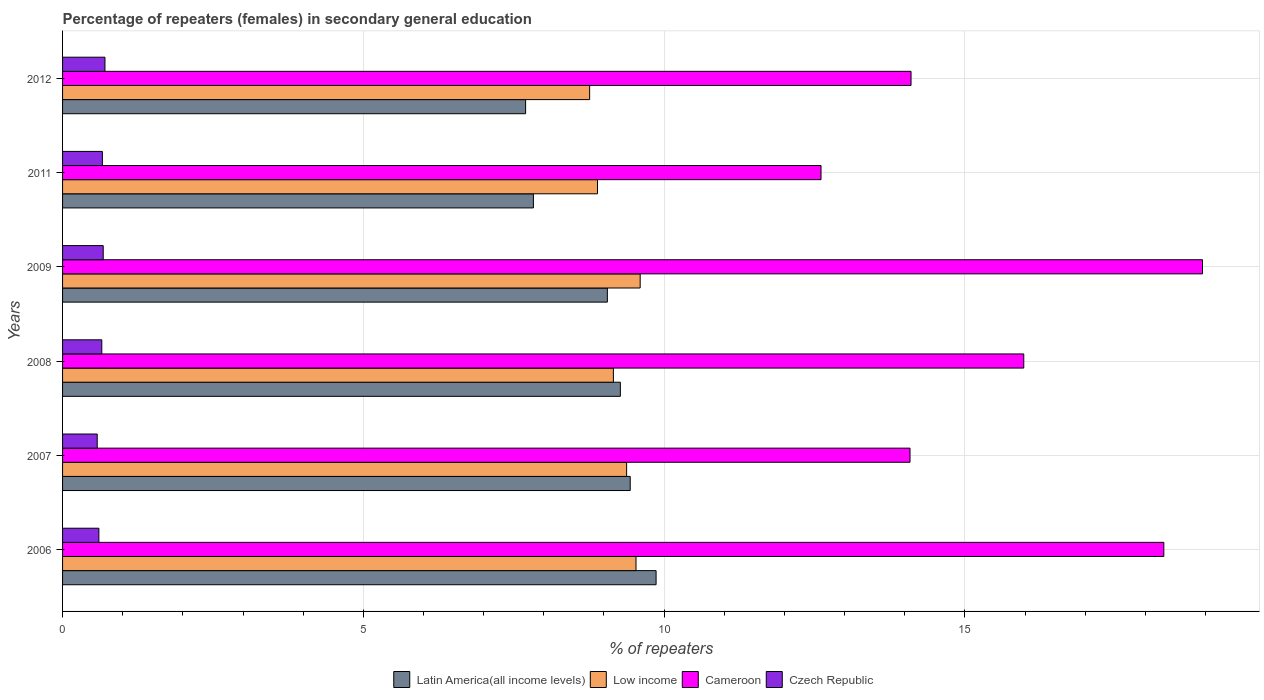Are the number of bars per tick equal to the number of legend labels?
Provide a succinct answer. Yes. How many bars are there on the 5th tick from the top?
Give a very brief answer. 4. How many bars are there on the 1st tick from the bottom?
Give a very brief answer. 4. What is the label of the 1st group of bars from the top?
Give a very brief answer. 2012. In how many cases, is the number of bars for a given year not equal to the number of legend labels?
Make the answer very short. 0. What is the percentage of female repeaters in Latin America(all income levels) in 2008?
Ensure brevity in your answer.  9.27. Across all years, what is the maximum percentage of female repeaters in Cameroon?
Your answer should be compact. 18.95. Across all years, what is the minimum percentage of female repeaters in Czech Republic?
Keep it short and to the point. 0.58. What is the total percentage of female repeaters in Czech Republic in the graph?
Your answer should be very brief. 3.87. What is the difference between the percentage of female repeaters in Low income in 2011 and that in 2012?
Provide a succinct answer. 0.13. What is the difference between the percentage of female repeaters in Low income in 2011 and the percentage of female repeaters in Czech Republic in 2008?
Give a very brief answer. 8.24. What is the average percentage of female repeaters in Czech Republic per year?
Keep it short and to the point. 0.65. In the year 2006, what is the difference between the percentage of female repeaters in Cameroon and percentage of female repeaters in Low income?
Your response must be concise. 8.77. In how many years, is the percentage of female repeaters in Latin America(all income levels) greater than 4 %?
Your answer should be compact. 6. What is the ratio of the percentage of female repeaters in Low income in 2011 to that in 2012?
Your answer should be compact. 1.01. Is the difference between the percentage of female repeaters in Cameroon in 2008 and 2009 greater than the difference between the percentage of female repeaters in Low income in 2008 and 2009?
Provide a succinct answer. No. What is the difference between the highest and the second highest percentage of female repeaters in Czech Republic?
Provide a short and direct response. 0.03. What is the difference between the highest and the lowest percentage of female repeaters in Latin America(all income levels)?
Your answer should be very brief. 2.17. What does the 3rd bar from the top in 2009 represents?
Give a very brief answer. Low income. What does the 3rd bar from the bottom in 2007 represents?
Make the answer very short. Cameroon. How many bars are there?
Provide a short and direct response. 24. How many years are there in the graph?
Your answer should be compact. 6. Are the values on the major ticks of X-axis written in scientific E-notation?
Give a very brief answer. No. Does the graph contain grids?
Ensure brevity in your answer.  Yes. Where does the legend appear in the graph?
Your response must be concise. Bottom center. What is the title of the graph?
Your response must be concise. Percentage of repeaters (females) in secondary general education. What is the label or title of the X-axis?
Provide a succinct answer. % of repeaters. What is the % of repeaters of Latin America(all income levels) in 2006?
Your answer should be compact. 9.87. What is the % of repeaters of Low income in 2006?
Keep it short and to the point. 9.53. What is the % of repeaters of Cameroon in 2006?
Give a very brief answer. 18.31. What is the % of repeaters in Czech Republic in 2006?
Provide a succinct answer. 0.6. What is the % of repeaters in Latin America(all income levels) in 2007?
Provide a short and direct response. 9.44. What is the % of repeaters of Low income in 2007?
Offer a very short reply. 9.38. What is the % of repeaters of Cameroon in 2007?
Provide a succinct answer. 14.09. What is the % of repeaters of Czech Republic in 2007?
Make the answer very short. 0.58. What is the % of repeaters of Latin America(all income levels) in 2008?
Provide a short and direct response. 9.27. What is the % of repeaters of Low income in 2008?
Your answer should be very brief. 9.16. What is the % of repeaters of Cameroon in 2008?
Offer a terse response. 15.98. What is the % of repeaters of Czech Republic in 2008?
Offer a very short reply. 0.65. What is the % of repeaters of Latin America(all income levels) in 2009?
Offer a very short reply. 9.06. What is the % of repeaters in Low income in 2009?
Keep it short and to the point. 9.6. What is the % of repeaters in Cameroon in 2009?
Keep it short and to the point. 18.95. What is the % of repeaters in Czech Republic in 2009?
Keep it short and to the point. 0.68. What is the % of repeaters in Latin America(all income levels) in 2011?
Your answer should be very brief. 7.83. What is the % of repeaters of Low income in 2011?
Make the answer very short. 8.89. What is the % of repeaters of Cameroon in 2011?
Keep it short and to the point. 12.61. What is the % of repeaters in Czech Republic in 2011?
Provide a succinct answer. 0.66. What is the % of repeaters in Latin America(all income levels) in 2012?
Keep it short and to the point. 7.7. What is the % of repeaters of Low income in 2012?
Make the answer very short. 8.76. What is the % of repeaters of Cameroon in 2012?
Ensure brevity in your answer.  14.1. What is the % of repeaters of Czech Republic in 2012?
Ensure brevity in your answer.  0.7. Across all years, what is the maximum % of repeaters of Latin America(all income levels)?
Ensure brevity in your answer.  9.87. Across all years, what is the maximum % of repeaters of Low income?
Give a very brief answer. 9.6. Across all years, what is the maximum % of repeaters of Cameroon?
Offer a terse response. 18.95. Across all years, what is the maximum % of repeaters in Czech Republic?
Ensure brevity in your answer.  0.7. Across all years, what is the minimum % of repeaters in Latin America(all income levels)?
Your answer should be very brief. 7.7. Across all years, what is the minimum % of repeaters in Low income?
Give a very brief answer. 8.76. Across all years, what is the minimum % of repeaters of Cameroon?
Your response must be concise. 12.61. Across all years, what is the minimum % of repeaters in Czech Republic?
Your response must be concise. 0.58. What is the total % of repeaters in Latin America(all income levels) in the graph?
Offer a very short reply. 53.16. What is the total % of repeaters of Low income in the graph?
Your answer should be compact. 55.32. What is the total % of repeaters of Cameroon in the graph?
Make the answer very short. 94.03. What is the total % of repeaters in Czech Republic in the graph?
Make the answer very short. 3.87. What is the difference between the % of repeaters in Latin America(all income levels) in 2006 and that in 2007?
Offer a terse response. 0.43. What is the difference between the % of repeaters of Low income in 2006 and that in 2007?
Offer a terse response. 0.16. What is the difference between the % of repeaters in Cameroon in 2006 and that in 2007?
Your response must be concise. 4.22. What is the difference between the % of repeaters of Czech Republic in 2006 and that in 2007?
Keep it short and to the point. 0.03. What is the difference between the % of repeaters in Latin America(all income levels) in 2006 and that in 2008?
Ensure brevity in your answer.  0.59. What is the difference between the % of repeaters of Low income in 2006 and that in 2008?
Give a very brief answer. 0.38. What is the difference between the % of repeaters of Cameroon in 2006 and that in 2008?
Your answer should be very brief. 2.33. What is the difference between the % of repeaters in Czech Republic in 2006 and that in 2008?
Offer a terse response. -0.05. What is the difference between the % of repeaters of Latin America(all income levels) in 2006 and that in 2009?
Your response must be concise. 0.81. What is the difference between the % of repeaters in Low income in 2006 and that in 2009?
Offer a very short reply. -0.07. What is the difference between the % of repeaters in Cameroon in 2006 and that in 2009?
Your answer should be very brief. -0.64. What is the difference between the % of repeaters in Czech Republic in 2006 and that in 2009?
Your answer should be compact. -0.07. What is the difference between the % of repeaters in Latin America(all income levels) in 2006 and that in 2011?
Provide a succinct answer. 2.04. What is the difference between the % of repeaters of Low income in 2006 and that in 2011?
Provide a succinct answer. 0.64. What is the difference between the % of repeaters of Cameroon in 2006 and that in 2011?
Offer a terse response. 5.7. What is the difference between the % of repeaters of Czech Republic in 2006 and that in 2011?
Your response must be concise. -0.06. What is the difference between the % of repeaters in Latin America(all income levels) in 2006 and that in 2012?
Your answer should be compact. 2.17. What is the difference between the % of repeaters in Low income in 2006 and that in 2012?
Your response must be concise. 0.77. What is the difference between the % of repeaters of Cameroon in 2006 and that in 2012?
Offer a terse response. 4.2. What is the difference between the % of repeaters in Czech Republic in 2006 and that in 2012?
Offer a terse response. -0.1. What is the difference between the % of repeaters in Latin America(all income levels) in 2007 and that in 2008?
Provide a succinct answer. 0.16. What is the difference between the % of repeaters of Low income in 2007 and that in 2008?
Offer a terse response. 0.22. What is the difference between the % of repeaters of Cameroon in 2007 and that in 2008?
Provide a succinct answer. -1.89. What is the difference between the % of repeaters in Czech Republic in 2007 and that in 2008?
Provide a succinct answer. -0.08. What is the difference between the % of repeaters in Latin America(all income levels) in 2007 and that in 2009?
Offer a very short reply. 0.38. What is the difference between the % of repeaters of Low income in 2007 and that in 2009?
Provide a succinct answer. -0.23. What is the difference between the % of repeaters in Cameroon in 2007 and that in 2009?
Your response must be concise. -4.86. What is the difference between the % of repeaters in Czech Republic in 2007 and that in 2009?
Provide a short and direct response. -0.1. What is the difference between the % of repeaters in Latin America(all income levels) in 2007 and that in 2011?
Provide a succinct answer. 1.61. What is the difference between the % of repeaters in Low income in 2007 and that in 2011?
Your answer should be very brief. 0.48. What is the difference between the % of repeaters of Cameroon in 2007 and that in 2011?
Provide a succinct answer. 1.48. What is the difference between the % of repeaters in Czech Republic in 2007 and that in 2011?
Keep it short and to the point. -0.09. What is the difference between the % of repeaters of Latin America(all income levels) in 2007 and that in 2012?
Offer a very short reply. 1.74. What is the difference between the % of repeaters in Low income in 2007 and that in 2012?
Keep it short and to the point. 0.61. What is the difference between the % of repeaters of Cameroon in 2007 and that in 2012?
Offer a terse response. -0.02. What is the difference between the % of repeaters of Czech Republic in 2007 and that in 2012?
Keep it short and to the point. -0.13. What is the difference between the % of repeaters of Latin America(all income levels) in 2008 and that in 2009?
Your answer should be very brief. 0.22. What is the difference between the % of repeaters in Low income in 2008 and that in 2009?
Give a very brief answer. -0.45. What is the difference between the % of repeaters in Cameroon in 2008 and that in 2009?
Offer a very short reply. -2.97. What is the difference between the % of repeaters in Czech Republic in 2008 and that in 2009?
Your answer should be very brief. -0.02. What is the difference between the % of repeaters in Latin America(all income levels) in 2008 and that in 2011?
Provide a succinct answer. 1.45. What is the difference between the % of repeaters in Low income in 2008 and that in 2011?
Provide a succinct answer. 0.26. What is the difference between the % of repeaters in Cameroon in 2008 and that in 2011?
Ensure brevity in your answer.  3.37. What is the difference between the % of repeaters of Czech Republic in 2008 and that in 2011?
Provide a succinct answer. -0.01. What is the difference between the % of repeaters of Latin America(all income levels) in 2008 and that in 2012?
Offer a terse response. 1.57. What is the difference between the % of repeaters of Low income in 2008 and that in 2012?
Provide a short and direct response. 0.39. What is the difference between the % of repeaters of Cameroon in 2008 and that in 2012?
Your answer should be very brief. 1.87. What is the difference between the % of repeaters of Czech Republic in 2008 and that in 2012?
Provide a short and direct response. -0.05. What is the difference between the % of repeaters in Latin America(all income levels) in 2009 and that in 2011?
Provide a short and direct response. 1.23. What is the difference between the % of repeaters in Low income in 2009 and that in 2011?
Make the answer very short. 0.71. What is the difference between the % of repeaters of Cameroon in 2009 and that in 2011?
Make the answer very short. 6.34. What is the difference between the % of repeaters in Czech Republic in 2009 and that in 2011?
Provide a short and direct response. 0.01. What is the difference between the % of repeaters of Latin America(all income levels) in 2009 and that in 2012?
Your answer should be very brief. 1.36. What is the difference between the % of repeaters in Low income in 2009 and that in 2012?
Offer a very short reply. 0.84. What is the difference between the % of repeaters of Cameroon in 2009 and that in 2012?
Keep it short and to the point. 4.85. What is the difference between the % of repeaters in Czech Republic in 2009 and that in 2012?
Give a very brief answer. -0.03. What is the difference between the % of repeaters of Latin America(all income levels) in 2011 and that in 2012?
Your answer should be very brief. 0.13. What is the difference between the % of repeaters in Low income in 2011 and that in 2012?
Give a very brief answer. 0.13. What is the difference between the % of repeaters of Cameroon in 2011 and that in 2012?
Make the answer very short. -1.5. What is the difference between the % of repeaters in Czech Republic in 2011 and that in 2012?
Make the answer very short. -0.04. What is the difference between the % of repeaters in Latin America(all income levels) in 2006 and the % of repeaters in Low income in 2007?
Offer a very short reply. 0.49. What is the difference between the % of repeaters of Latin America(all income levels) in 2006 and the % of repeaters of Cameroon in 2007?
Offer a very short reply. -4.22. What is the difference between the % of repeaters of Latin America(all income levels) in 2006 and the % of repeaters of Czech Republic in 2007?
Your answer should be compact. 9.29. What is the difference between the % of repeaters of Low income in 2006 and the % of repeaters of Cameroon in 2007?
Give a very brief answer. -4.55. What is the difference between the % of repeaters of Low income in 2006 and the % of repeaters of Czech Republic in 2007?
Your response must be concise. 8.96. What is the difference between the % of repeaters of Cameroon in 2006 and the % of repeaters of Czech Republic in 2007?
Your answer should be compact. 17.73. What is the difference between the % of repeaters in Latin America(all income levels) in 2006 and the % of repeaters in Low income in 2008?
Give a very brief answer. 0.71. What is the difference between the % of repeaters in Latin America(all income levels) in 2006 and the % of repeaters in Cameroon in 2008?
Your response must be concise. -6.11. What is the difference between the % of repeaters in Latin America(all income levels) in 2006 and the % of repeaters in Czech Republic in 2008?
Your answer should be very brief. 9.21. What is the difference between the % of repeaters of Low income in 2006 and the % of repeaters of Cameroon in 2008?
Give a very brief answer. -6.45. What is the difference between the % of repeaters of Low income in 2006 and the % of repeaters of Czech Republic in 2008?
Keep it short and to the point. 8.88. What is the difference between the % of repeaters of Cameroon in 2006 and the % of repeaters of Czech Republic in 2008?
Provide a succinct answer. 17.65. What is the difference between the % of repeaters of Latin America(all income levels) in 2006 and the % of repeaters of Low income in 2009?
Your response must be concise. 0.26. What is the difference between the % of repeaters in Latin America(all income levels) in 2006 and the % of repeaters in Cameroon in 2009?
Provide a succinct answer. -9.08. What is the difference between the % of repeaters in Latin America(all income levels) in 2006 and the % of repeaters in Czech Republic in 2009?
Make the answer very short. 9.19. What is the difference between the % of repeaters of Low income in 2006 and the % of repeaters of Cameroon in 2009?
Your response must be concise. -9.42. What is the difference between the % of repeaters of Low income in 2006 and the % of repeaters of Czech Republic in 2009?
Keep it short and to the point. 8.86. What is the difference between the % of repeaters in Cameroon in 2006 and the % of repeaters in Czech Republic in 2009?
Ensure brevity in your answer.  17.63. What is the difference between the % of repeaters of Latin America(all income levels) in 2006 and the % of repeaters of Low income in 2011?
Make the answer very short. 0.97. What is the difference between the % of repeaters of Latin America(all income levels) in 2006 and the % of repeaters of Cameroon in 2011?
Your answer should be very brief. -2.74. What is the difference between the % of repeaters of Latin America(all income levels) in 2006 and the % of repeaters of Czech Republic in 2011?
Your answer should be very brief. 9.2. What is the difference between the % of repeaters of Low income in 2006 and the % of repeaters of Cameroon in 2011?
Your answer should be very brief. -3.08. What is the difference between the % of repeaters in Low income in 2006 and the % of repeaters in Czech Republic in 2011?
Ensure brevity in your answer.  8.87. What is the difference between the % of repeaters of Cameroon in 2006 and the % of repeaters of Czech Republic in 2011?
Keep it short and to the point. 17.64. What is the difference between the % of repeaters of Latin America(all income levels) in 2006 and the % of repeaters of Low income in 2012?
Your answer should be compact. 1.1. What is the difference between the % of repeaters in Latin America(all income levels) in 2006 and the % of repeaters in Cameroon in 2012?
Your response must be concise. -4.24. What is the difference between the % of repeaters of Latin America(all income levels) in 2006 and the % of repeaters of Czech Republic in 2012?
Your response must be concise. 9.16. What is the difference between the % of repeaters of Low income in 2006 and the % of repeaters of Cameroon in 2012?
Ensure brevity in your answer.  -4.57. What is the difference between the % of repeaters of Low income in 2006 and the % of repeaters of Czech Republic in 2012?
Provide a short and direct response. 8.83. What is the difference between the % of repeaters in Cameroon in 2006 and the % of repeaters in Czech Republic in 2012?
Your answer should be compact. 17.6. What is the difference between the % of repeaters in Latin America(all income levels) in 2007 and the % of repeaters in Low income in 2008?
Give a very brief answer. 0.28. What is the difference between the % of repeaters in Latin America(all income levels) in 2007 and the % of repeaters in Cameroon in 2008?
Provide a succinct answer. -6.54. What is the difference between the % of repeaters of Latin America(all income levels) in 2007 and the % of repeaters of Czech Republic in 2008?
Provide a short and direct response. 8.78. What is the difference between the % of repeaters of Low income in 2007 and the % of repeaters of Cameroon in 2008?
Your answer should be compact. -6.6. What is the difference between the % of repeaters in Low income in 2007 and the % of repeaters in Czech Republic in 2008?
Offer a very short reply. 8.72. What is the difference between the % of repeaters of Cameroon in 2007 and the % of repeaters of Czech Republic in 2008?
Offer a terse response. 13.44. What is the difference between the % of repeaters of Latin America(all income levels) in 2007 and the % of repeaters of Low income in 2009?
Give a very brief answer. -0.17. What is the difference between the % of repeaters of Latin America(all income levels) in 2007 and the % of repeaters of Cameroon in 2009?
Make the answer very short. -9.51. What is the difference between the % of repeaters in Latin America(all income levels) in 2007 and the % of repeaters in Czech Republic in 2009?
Your answer should be very brief. 8.76. What is the difference between the % of repeaters in Low income in 2007 and the % of repeaters in Cameroon in 2009?
Offer a terse response. -9.57. What is the difference between the % of repeaters in Low income in 2007 and the % of repeaters in Czech Republic in 2009?
Ensure brevity in your answer.  8.7. What is the difference between the % of repeaters in Cameroon in 2007 and the % of repeaters in Czech Republic in 2009?
Your answer should be compact. 13.41. What is the difference between the % of repeaters in Latin America(all income levels) in 2007 and the % of repeaters in Low income in 2011?
Your answer should be compact. 0.54. What is the difference between the % of repeaters of Latin America(all income levels) in 2007 and the % of repeaters of Cameroon in 2011?
Give a very brief answer. -3.17. What is the difference between the % of repeaters of Latin America(all income levels) in 2007 and the % of repeaters of Czech Republic in 2011?
Offer a terse response. 8.77. What is the difference between the % of repeaters of Low income in 2007 and the % of repeaters of Cameroon in 2011?
Provide a succinct answer. -3.23. What is the difference between the % of repeaters of Low income in 2007 and the % of repeaters of Czech Republic in 2011?
Your answer should be very brief. 8.71. What is the difference between the % of repeaters in Cameroon in 2007 and the % of repeaters in Czech Republic in 2011?
Give a very brief answer. 13.43. What is the difference between the % of repeaters in Latin America(all income levels) in 2007 and the % of repeaters in Low income in 2012?
Offer a very short reply. 0.67. What is the difference between the % of repeaters of Latin America(all income levels) in 2007 and the % of repeaters of Cameroon in 2012?
Ensure brevity in your answer.  -4.67. What is the difference between the % of repeaters of Latin America(all income levels) in 2007 and the % of repeaters of Czech Republic in 2012?
Provide a succinct answer. 8.73. What is the difference between the % of repeaters in Low income in 2007 and the % of repeaters in Cameroon in 2012?
Provide a succinct answer. -4.73. What is the difference between the % of repeaters in Low income in 2007 and the % of repeaters in Czech Republic in 2012?
Offer a terse response. 8.67. What is the difference between the % of repeaters of Cameroon in 2007 and the % of repeaters of Czech Republic in 2012?
Offer a terse response. 13.38. What is the difference between the % of repeaters in Latin America(all income levels) in 2008 and the % of repeaters in Low income in 2009?
Offer a very short reply. -0.33. What is the difference between the % of repeaters in Latin America(all income levels) in 2008 and the % of repeaters in Cameroon in 2009?
Provide a succinct answer. -9.68. What is the difference between the % of repeaters of Latin America(all income levels) in 2008 and the % of repeaters of Czech Republic in 2009?
Your answer should be very brief. 8.6. What is the difference between the % of repeaters in Low income in 2008 and the % of repeaters in Cameroon in 2009?
Your answer should be compact. -9.79. What is the difference between the % of repeaters in Low income in 2008 and the % of repeaters in Czech Republic in 2009?
Your answer should be very brief. 8.48. What is the difference between the % of repeaters in Cameroon in 2008 and the % of repeaters in Czech Republic in 2009?
Ensure brevity in your answer.  15.3. What is the difference between the % of repeaters of Latin America(all income levels) in 2008 and the % of repeaters of Low income in 2011?
Make the answer very short. 0.38. What is the difference between the % of repeaters of Latin America(all income levels) in 2008 and the % of repeaters of Cameroon in 2011?
Make the answer very short. -3.34. What is the difference between the % of repeaters in Latin America(all income levels) in 2008 and the % of repeaters in Czech Republic in 2011?
Give a very brief answer. 8.61. What is the difference between the % of repeaters of Low income in 2008 and the % of repeaters of Cameroon in 2011?
Keep it short and to the point. -3.45. What is the difference between the % of repeaters in Low income in 2008 and the % of repeaters in Czech Republic in 2011?
Offer a very short reply. 8.49. What is the difference between the % of repeaters in Cameroon in 2008 and the % of repeaters in Czech Republic in 2011?
Provide a succinct answer. 15.32. What is the difference between the % of repeaters of Latin America(all income levels) in 2008 and the % of repeaters of Low income in 2012?
Give a very brief answer. 0.51. What is the difference between the % of repeaters in Latin America(all income levels) in 2008 and the % of repeaters in Cameroon in 2012?
Ensure brevity in your answer.  -4.83. What is the difference between the % of repeaters in Latin America(all income levels) in 2008 and the % of repeaters in Czech Republic in 2012?
Ensure brevity in your answer.  8.57. What is the difference between the % of repeaters of Low income in 2008 and the % of repeaters of Cameroon in 2012?
Make the answer very short. -4.95. What is the difference between the % of repeaters in Low income in 2008 and the % of repeaters in Czech Republic in 2012?
Offer a very short reply. 8.45. What is the difference between the % of repeaters in Cameroon in 2008 and the % of repeaters in Czech Republic in 2012?
Give a very brief answer. 15.27. What is the difference between the % of repeaters in Latin America(all income levels) in 2009 and the % of repeaters in Low income in 2011?
Provide a succinct answer. 0.16. What is the difference between the % of repeaters in Latin America(all income levels) in 2009 and the % of repeaters in Cameroon in 2011?
Offer a terse response. -3.55. What is the difference between the % of repeaters of Latin America(all income levels) in 2009 and the % of repeaters of Czech Republic in 2011?
Ensure brevity in your answer.  8.39. What is the difference between the % of repeaters in Low income in 2009 and the % of repeaters in Cameroon in 2011?
Keep it short and to the point. -3.01. What is the difference between the % of repeaters of Low income in 2009 and the % of repeaters of Czech Republic in 2011?
Provide a short and direct response. 8.94. What is the difference between the % of repeaters in Cameroon in 2009 and the % of repeaters in Czech Republic in 2011?
Provide a succinct answer. 18.29. What is the difference between the % of repeaters of Latin America(all income levels) in 2009 and the % of repeaters of Low income in 2012?
Provide a short and direct response. 0.29. What is the difference between the % of repeaters of Latin America(all income levels) in 2009 and the % of repeaters of Cameroon in 2012?
Provide a succinct answer. -5.05. What is the difference between the % of repeaters in Latin America(all income levels) in 2009 and the % of repeaters in Czech Republic in 2012?
Give a very brief answer. 8.35. What is the difference between the % of repeaters in Low income in 2009 and the % of repeaters in Cameroon in 2012?
Provide a short and direct response. -4.5. What is the difference between the % of repeaters in Low income in 2009 and the % of repeaters in Czech Republic in 2012?
Provide a succinct answer. 8.9. What is the difference between the % of repeaters in Cameroon in 2009 and the % of repeaters in Czech Republic in 2012?
Offer a terse response. 18.24. What is the difference between the % of repeaters in Latin America(all income levels) in 2011 and the % of repeaters in Low income in 2012?
Give a very brief answer. -0.93. What is the difference between the % of repeaters in Latin America(all income levels) in 2011 and the % of repeaters in Cameroon in 2012?
Offer a very short reply. -6.28. What is the difference between the % of repeaters in Latin America(all income levels) in 2011 and the % of repeaters in Czech Republic in 2012?
Your answer should be very brief. 7.12. What is the difference between the % of repeaters of Low income in 2011 and the % of repeaters of Cameroon in 2012?
Make the answer very short. -5.21. What is the difference between the % of repeaters in Low income in 2011 and the % of repeaters in Czech Republic in 2012?
Provide a succinct answer. 8.19. What is the difference between the % of repeaters in Cameroon in 2011 and the % of repeaters in Czech Republic in 2012?
Offer a very short reply. 11.9. What is the average % of repeaters of Latin America(all income levels) per year?
Your answer should be very brief. 8.86. What is the average % of repeaters of Low income per year?
Offer a very short reply. 9.22. What is the average % of repeaters of Cameroon per year?
Offer a terse response. 15.67. What is the average % of repeaters of Czech Republic per year?
Your answer should be compact. 0.65. In the year 2006, what is the difference between the % of repeaters in Latin America(all income levels) and % of repeaters in Low income?
Keep it short and to the point. 0.33. In the year 2006, what is the difference between the % of repeaters of Latin America(all income levels) and % of repeaters of Cameroon?
Make the answer very short. -8.44. In the year 2006, what is the difference between the % of repeaters of Latin America(all income levels) and % of repeaters of Czech Republic?
Offer a terse response. 9.26. In the year 2006, what is the difference between the % of repeaters of Low income and % of repeaters of Cameroon?
Give a very brief answer. -8.77. In the year 2006, what is the difference between the % of repeaters of Low income and % of repeaters of Czech Republic?
Ensure brevity in your answer.  8.93. In the year 2006, what is the difference between the % of repeaters of Cameroon and % of repeaters of Czech Republic?
Give a very brief answer. 17.7. In the year 2007, what is the difference between the % of repeaters of Latin America(all income levels) and % of repeaters of Low income?
Provide a succinct answer. 0.06. In the year 2007, what is the difference between the % of repeaters of Latin America(all income levels) and % of repeaters of Cameroon?
Provide a succinct answer. -4.65. In the year 2007, what is the difference between the % of repeaters in Latin America(all income levels) and % of repeaters in Czech Republic?
Your response must be concise. 8.86. In the year 2007, what is the difference between the % of repeaters of Low income and % of repeaters of Cameroon?
Give a very brief answer. -4.71. In the year 2007, what is the difference between the % of repeaters of Low income and % of repeaters of Czech Republic?
Keep it short and to the point. 8.8. In the year 2007, what is the difference between the % of repeaters in Cameroon and % of repeaters in Czech Republic?
Make the answer very short. 13.51. In the year 2008, what is the difference between the % of repeaters of Latin America(all income levels) and % of repeaters of Low income?
Your answer should be compact. 0.12. In the year 2008, what is the difference between the % of repeaters of Latin America(all income levels) and % of repeaters of Cameroon?
Give a very brief answer. -6.71. In the year 2008, what is the difference between the % of repeaters of Latin America(all income levels) and % of repeaters of Czech Republic?
Offer a very short reply. 8.62. In the year 2008, what is the difference between the % of repeaters in Low income and % of repeaters in Cameroon?
Offer a terse response. -6.82. In the year 2008, what is the difference between the % of repeaters in Low income and % of repeaters in Czech Republic?
Keep it short and to the point. 8.5. In the year 2008, what is the difference between the % of repeaters of Cameroon and % of repeaters of Czech Republic?
Your answer should be compact. 15.33. In the year 2009, what is the difference between the % of repeaters in Latin America(all income levels) and % of repeaters in Low income?
Your response must be concise. -0.55. In the year 2009, what is the difference between the % of repeaters in Latin America(all income levels) and % of repeaters in Cameroon?
Provide a short and direct response. -9.89. In the year 2009, what is the difference between the % of repeaters of Latin America(all income levels) and % of repeaters of Czech Republic?
Ensure brevity in your answer.  8.38. In the year 2009, what is the difference between the % of repeaters of Low income and % of repeaters of Cameroon?
Provide a short and direct response. -9.35. In the year 2009, what is the difference between the % of repeaters in Low income and % of repeaters in Czech Republic?
Provide a succinct answer. 8.93. In the year 2009, what is the difference between the % of repeaters of Cameroon and % of repeaters of Czech Republic?
Offer a very short reply. 18.27. In the year 2011, what is the difference between the % of repeaters of Latin America(all income levels) and % of repeaters of Low income?
Offer a terse response. -1.07. In the year 2011, what is the difference between the % of repeaters in Latin America(all income levels) and % of repeaters in Cameroon?
Provide a short and direct response. -4.78. In the year 2011, what is the difference between the % of repeaters of Latin America(all income levels) and % of repeaters of Czech Republic?
Ensure brevity in your answer.  7.17. In the year 2011, what is the difference between the % of repeaters of Low income and % of repeaters of Cameroon?
Provide a short and direct response. -3.72. In the year 2011, what is the difference between the % of repeaters in Low income and % of repeaters in Czech Republic?
Give a very brief answer. 8.23. In the year 2011, what is the difference between the % of repeaters in Cameroon and % of repeaters in Czech Republic?
Offer a terse response. 11.95. In the year 2012, what is the difference between the % of repeaters of Latin America(all income levels) and % of repeaters of Low income?
Offer a very short reply. -1.06. In the year 2012, what is the difference between the % of repeaters of Latin America(all income levels) and % of repeaters of Cameroon?
Offer a very short reply. -6.41. In the year 2012, what is the difference between the % of repeaters in Latin America(all income levels) and % of repeaters in Czech Republic?
Provide a succinct answer. 6.99. In the year 2012, what is the difference between the % of repeaters of Low income and % of repeaters of Cameroon?
Provide a short and direct response. -5.34. In the year 2012, what is the difference between the % of repeaters in Low income and % of repeaters in Czech Republic?
Give a very brief answer. 8.06. In the year 2012, what is the difference between the % of repeaters in Cameroon and % of repeaters in Czech Republic?
Your answer should be very brief. 13.4. What is the ratio of the % of repeaters in Latin America(all income levels) in 2006 to that in 2007?
Give a very brief answer. 1.05. What is the ratio of the % of repeaters of Low income in 2006 to that in 2007?
Keep it short and to the point. 1.02. What is the ratio of the % of repeaters of Cameroon in 2006 to that in 2007?
Your response must be concise. 1.3. What is the ratio of the % of repeaters in Czech Republic in 2006 to that in 2007?
Give a very brief answer. 1.05. What is the ratio of the % of repeaters of Latin America(all income levels) in 2006 to that in 2008?
Keep it short and to the point. 1.06. What is the ratio of the % of repeaters of Low income in 2006 to that in 2008?
Your answer should be very brief. 1.04. What is the ratio of the % of repeaters of Cameroon in 2006 to that in 2008?
Your answer should be very brief. 1.15. What is the ratio of the % of repeaters of Czech Republic in 2006 to that in 2008?
Give a very brief answer. 0.93. What is the ratio of the % of repeaters in Latin America(all income levels) in 2006 to that in 2009?
Offer a terse response. 1.09. What is the ratio of the % of repeaters of Low income in 2006 to that in 2009?
Your answer should be compact. 0.99. What is the ratio of the % of repeaters in Cameroon in 2006 to that in 2009?
Make the answer very short. 0.97. What is the ratio of the % of repeaters of Czech Republic in 2006 to that in 2009?
Give a very brief answer. 0.89. What is the ratio of the % of repeaters of Latin America(all income levels) in 2006 to that in 2011?
Give a very brief answer. 1.26. What is the ratio of the % of repeaters in Low income in 2006 to that in 2011?
Your answer should be compact. 1.07. What is the ratio of the % of repeaters in Cameroon in 2006 to that in 2011?
Your answer should be compact. 1.45. What is the ratio of the % of repeaters in Czech Republic in 2006 to that in 2011?
Ensure brevity in your answer.  0.91. What is the ratio of the % of repeaters of Latin America(all income levels) in 2006 to that in 2012?
Provide a succinct answer. 1.28. What is the ratio of the % of repeaters of Low income in 2006 to that in 2012?
Give a very brief answer. 1.09. What is the ratio of the % of repeaters of Cameroon in 2006 to that in 2012?
Provide a short and direct response. 1.3. What is the ratio of the % of repeaters in Czech Republic in 2006 to that in 2012?
Make the answer very short. 0.86. What is the ratio of the % of repeaters in Latin America(all income levels) in 2007 to that in 2008?
Provide a short and direct response. 1.02. What is the ratio of the % of repeaters of Cameroon in 2007 to that in 2008?
Your response must be concise. 0.88. What is the ratio of the % of repeaters in Czech Republic in 2007 to that in 2008?
Keep it short and to the point. 0.88. What is the ratio of the % of repeaters in Latin America(all income levels) in 2007 to that in 2009?
Offer a terse response. 1.04. What is the ratio of the % of repeaters of Low income in 2007 to that in 2009?
Make the answer very short. 0.98. What is the ratio of the % of repeaters of Cameroon in 2007 to that in 2009?
Offer a very short reply. 0.74. What is the ratio of the % of repeaters in Czech Republic in 2007 to that in 2009?
Your answer should be very brief. 0.85. What is the ratio of the % of repeaters in Latin America(all income levels) in 2007 to that in 2011?
Ensure brevity in your answer.  1.21. What is the ratio of the % of repeaters in Low income in 2007 to that in 2011?
Provide a succinct answer. 1.05. What is the ratio of the % of repeaters in Cameroon in 2007 to that in 2011?
Ensure brevity in your answer.  1.12. What is the ratio of the % of repeaters of Czech Republic in 2007 to that in 2011?
Your answer should be compact. 0.87. What is the ratio of the % of repeaters of Latin America(all income levels) in 2007 to that in 2012?
Provide a succinct answer. 1.23. What is the ratio of the % of repeaters of Low income in 2007 to that in 2012?
Keep it short and to the point. 1.07. What is the ratio of the % of repeaters in Cameroon in 2007 to that in 2012?
Provide a succinct answer. 1. What is the ratio of the % of repeaters in Czech Republic in 2007 to that in 2012?
Ensure brevity in your answer.  0.82. What is the ratio of the % of repeaters in Latin America(all income levels) in 2008 to that in 2009?
Give a very brief answer. 1.02. What is the ratio of the % of repeaters in Low income in 2008 to that in 2009?
Ensure brevity in your answer.  0.95. What is the ratio of the % of repeaters in Cameroon in 2008 to that in 2009?
Give a very brief answer. 0.84. What is the ratio of the % of repeaters of Czech Republic in 2008 to that in 2009?
Give a very brief answer. 0.97. What is the ratio of the % of repeaters in Latin America(all income levels) in 2008 to that in 2011?
Offer a very short reply. 1.18. What is the ratio of the % of repeaters in Low income in 2008 to that in 2011?
Keep it short and to the point. 1.03. What is the ratio of the % of repeaters of Cameroon in 2008 to that in 2011?
Offer a very short reply. 1.27. What is the ratio of the % of repeaters in Czech Republic in 2008 to that in 2011?
Your answer should be compact. 0.99. What is the ratio of the % of repeaters of Latin America(all income levels) in 2008 to that in 2012?
Your response must be concise. 1.2. What is the ratio of the % of repeaters in Low income in 2008 to that in 2012?
Keep it short and to the point. 1.05. What is the ratio of the % of repeaters of Cameroon in 2008 to that in 2012?
Provide a short and direct response. 1.13. What is the ratio of the % of repeaters in Czech Republic in 2008 to that in 2012?
Your response must be concise. 0.93. What is the ratio of the % of repeaters of Latin America(all income levels) in 2009 to that in 2011?
Keep it short and to the point. 1.16. What is the ratio of the % of repeaters in Low income in 2009 to that in 2011?
Your answer should be compact. 1.08. What is the ratio of the % of repeaters in Cameroon in 2009 to that in 2011?
Give a very brief answer. 1.5. What is the ratio of the % of repeaters of Czech Republic in 2009 to that in 2011?
Keep it short and to the point. 1.02. What is the ratio of the % of repeaters of Latin America(all income levels) in 2009 to that in 2012?
Your response must be concise. 1.18. What is the ratio of the % of repeaters of Low income in 2009 to that in 2012?
Give a very brief answer. 1.1. What is the ratio of the % of repeaters of Cameroon in 2009 to that in 2012?
Your answer should be very brief. 1.34. What is the ratio of the % of repeaters in Czech Republic in 2009 to that in 2012?
Keep it short and to the point. 0.96. What is the ratio of the % of repeaters in Latin America(all income levels) in 2011 to that in 2012?
Offer a very short reply. 1.02. What is the ratio of the % of repeaters of Low income in 2011 to that in 2012?
Offer a terse response. 1.01. What is the ratio of the % of repeaters of Cameroon in 2011 to that in 2012?
Offer a very short reply. 0.89. What is the ratio of the % of repeaters in Czech Republic in 2011 to that in 2012?
Keep it short and to the point. 0.94. What is the difference between the highest and the second highest % of repeaters in Latin America(all income levels)?
Offer a terse response. 0.43. What is the difference between the highest and the second highest % of repeaters of Low income?
Give a very brief answer. 0.07. What is the difference between the highest and the second highest % of repeaters of Cameroon?
Your answer should be compact. 0.64. What is the difference between the highest and the second highest % of repeaters in Czech Republic?
Ensure brevity in your answer.  0.03. What is the difference between the highest and the lowest % of repeaters in Latin America(all income levels)?
Offer a very short reply. 2.17. What is the difference between the highest and the lowest % of repeaters in Low income?
Your response must be concise. 0.84. What is the difference between the highest and the lowest % of repeaters in Cameroon?
Keep it short and to the point. 6.34. What is the difference between the highest and the lowest % of repeaters of Czech Republic?
Your response must be concise. 0.13. 